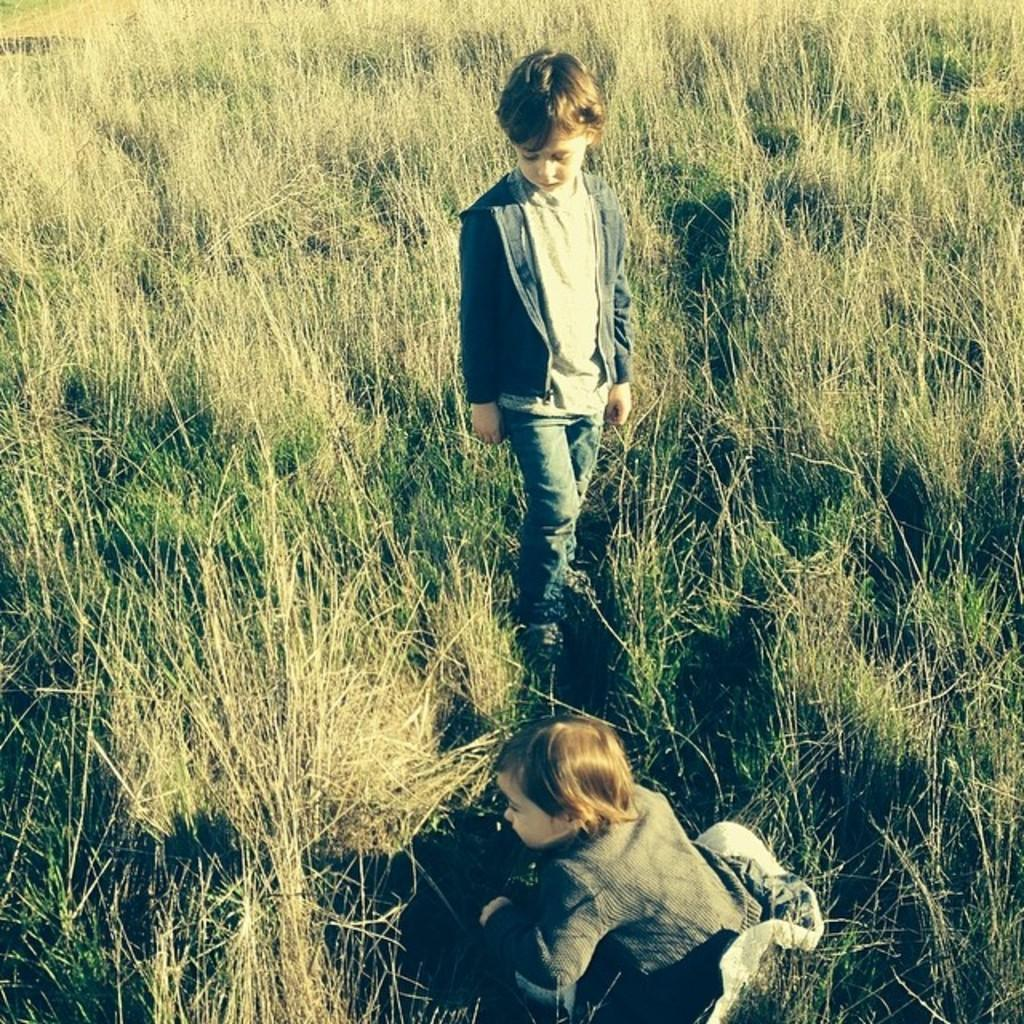What is the position of the girl in the image? The girl is sitting at the bottom of the picture. Who is standing beside the girl? There is a boy in a grey T-shirt standing beside the girl. What can be seen in the background of the picture? There is grass visible in the background of the picture. What type of scarf is the monkey wearing in the image? There is no monkey or scarf present in the image. How many beds can be seen in the image? There are no beds visible in the image. 